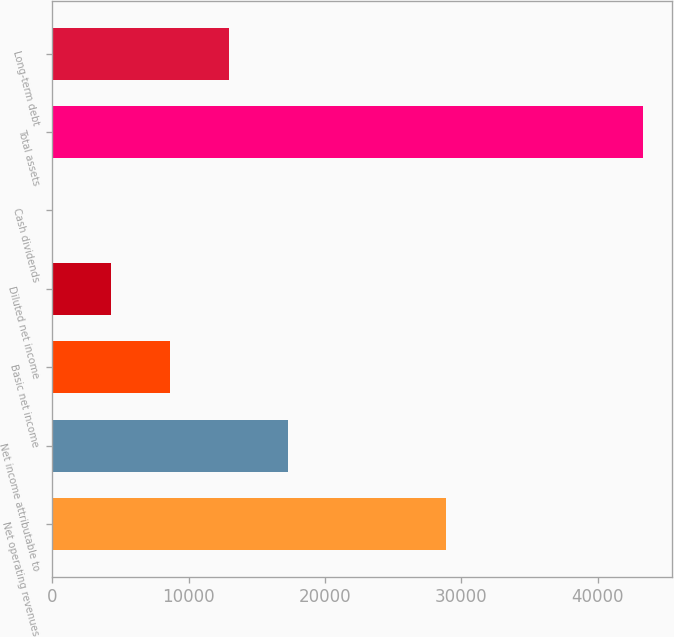Convert chart. <chart><loc_0><loc_0><loc_500><loc_500><bar_chart><fcel>Net operating revenues<fcel>Net income attributable to<fcel>Basic net income<fcel>Diluted net income<fcel>Cash dividends<fcel>Total assets<fcel>Long-term debt<nl><fcel>28857<fcel>17308.4<fcel>8654.88<fcel>4328.12<fcel>1.36<fcel>43269<fcel>12981.6<nl></chart> 